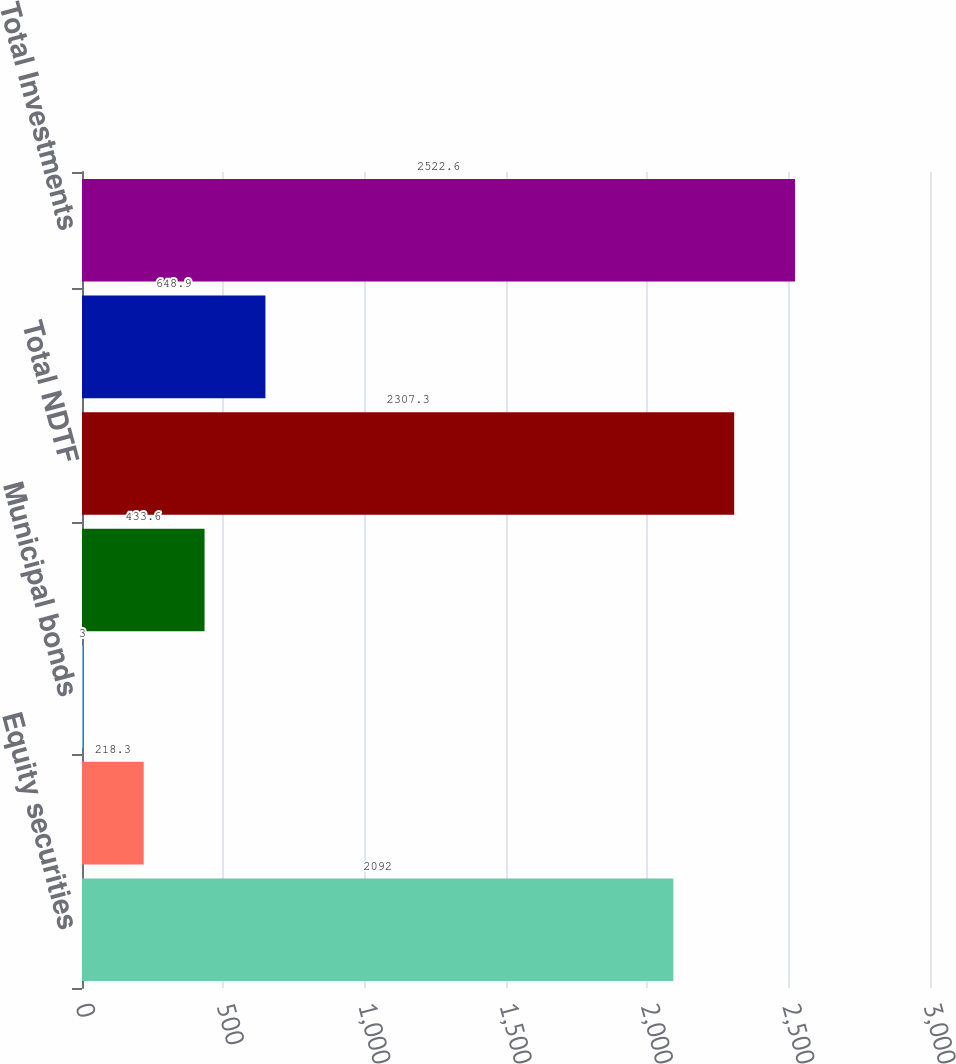<chart> <loc_0><loc_0><loc_500><loc_500><bar_chart><fcel>Equity securities<fcel>Corporate debt securities<fcel>Municipal bonds<fcel>US government bonds<fcel>Total NDTF<fcel>Total Other Investments<fcel>Total Investments<nl><fcel>2092<fcel>218.3<fcel>3<fcel>433.6<fcel>2307.3<fcel>648.9<fcel>2522.6<nl></chart> 